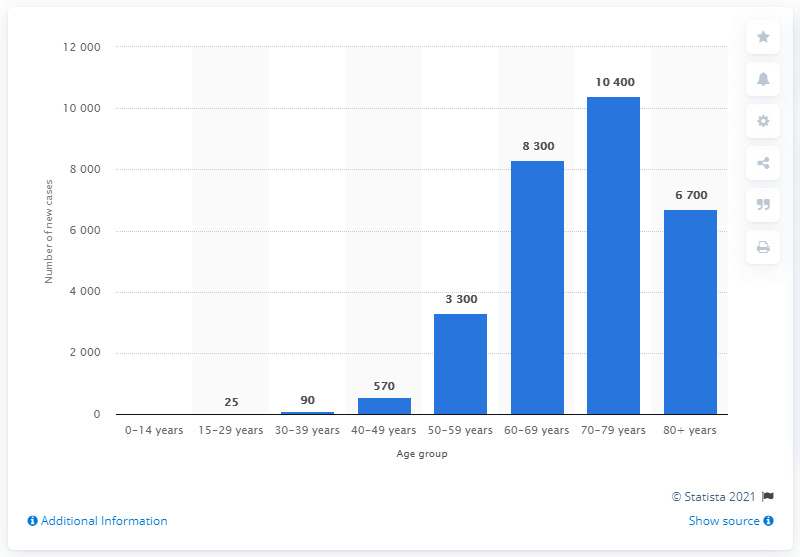Indicate a few pertinent items in this graphic. In 2019, it is estimated that 25 new lung cancer cases will occur among individuals aged 15-29. 